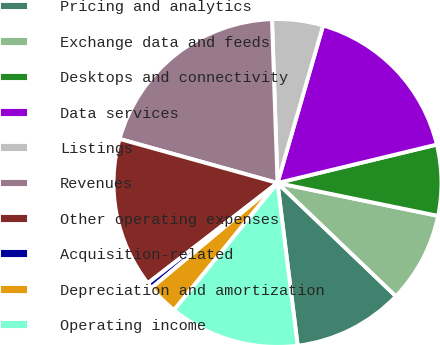Convert chart. <chart><loc_0><loc_0><loc_500><loc_500><pie_chart><fcel>Pricing and analytics<fcel>Exchange data and feeds<fcel>Desktops and connectivity<fcel>Data services<fcel>Listings<fcel>Revenues<fcel>Other operating expenses<fcel>Acquisition-related<fcel>Depreciation and amortization<fcel>Operating income<nl><fcel>10.89%<fcel>8.93%<fcel>6.98%<fcel>16.75%<fcel>5.02%<fcel>20.14%<fcel>14.8%<fcel>0.58%<fcel>3.07%<fcel>12.84%<nl></chart> 